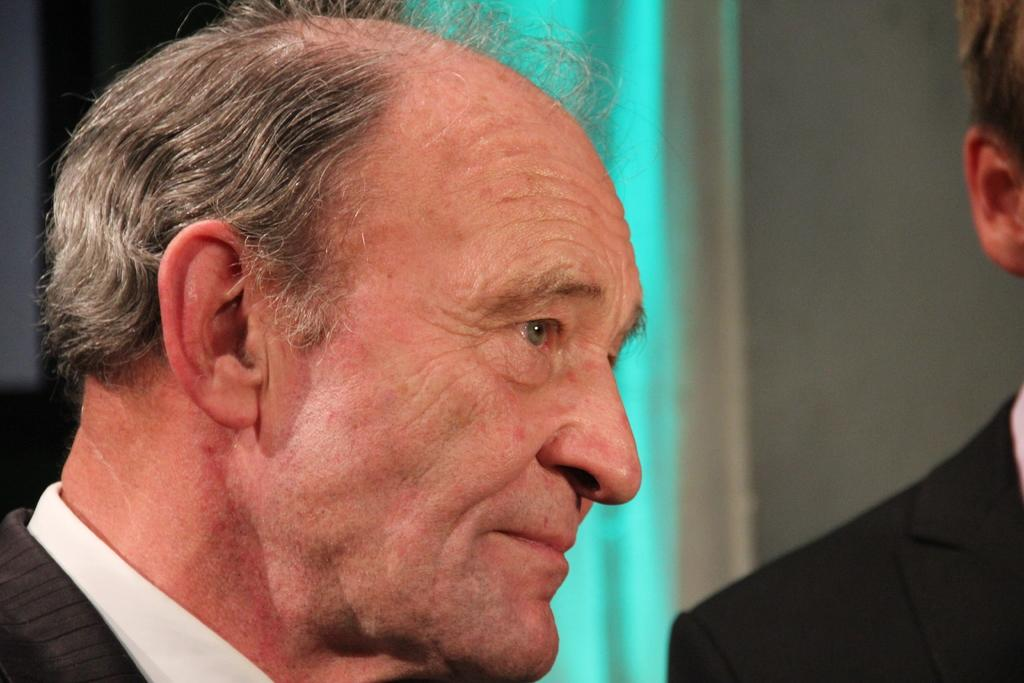How many people are in the image? There are two men in the image. What is one of the men wearing? One of the men is wearing a blazer. What can be seen in the background of the image? There is a wall visible in the background of the image. What type of potato is being used for scientific experiments in the image? There is no potato or scientific experiment present in the image. Can you tell me how many tanks are visible in the image? There are no tanks visible in the image. 